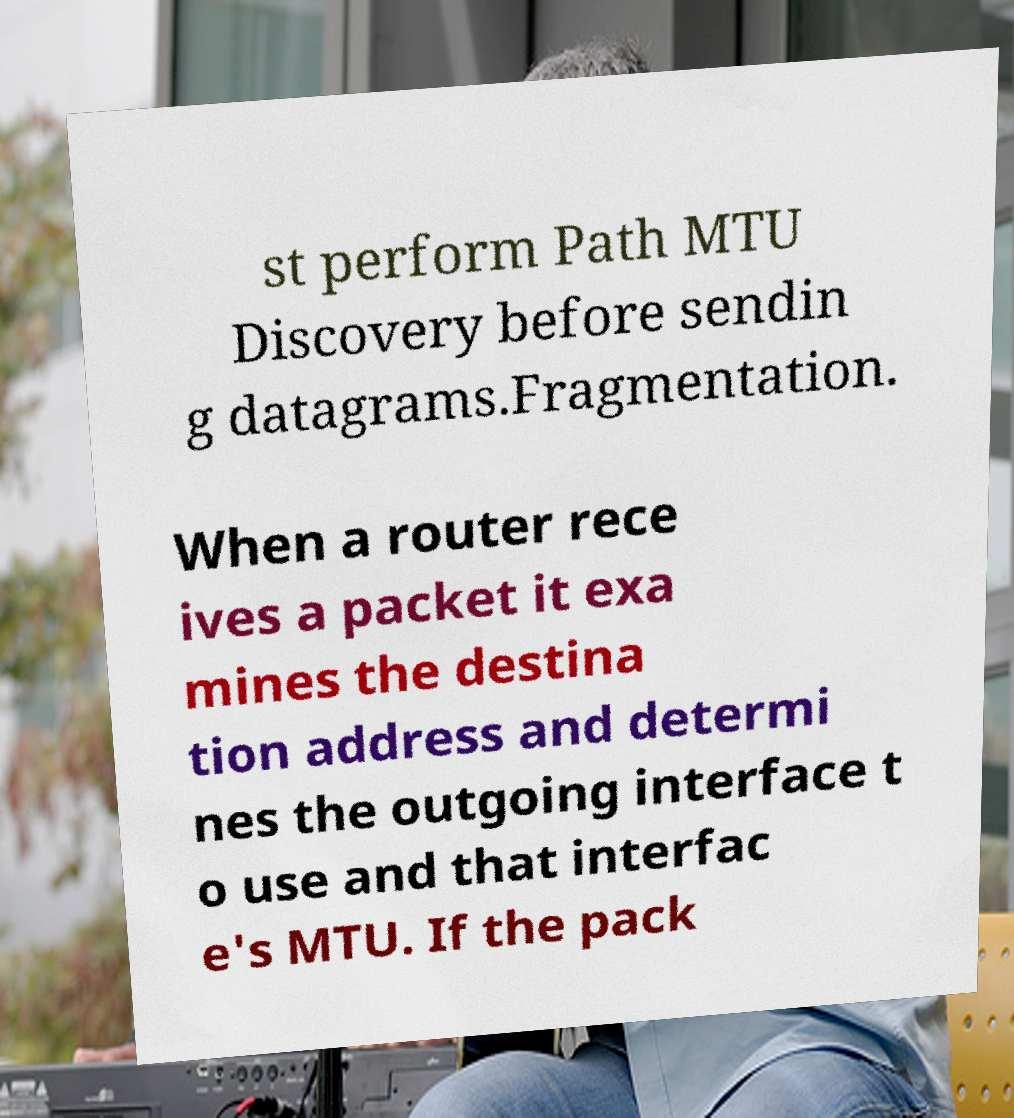What messages or text are displayed in this image? I need them in a readable, typed format. st perform Path MTU Discovery before sendin g datagrams.Fragmentation. When a router rece ives a packet it exa mines the destina tion address and determi nes the outgoing interface t o use and that interfac e's MTU. If the pack 